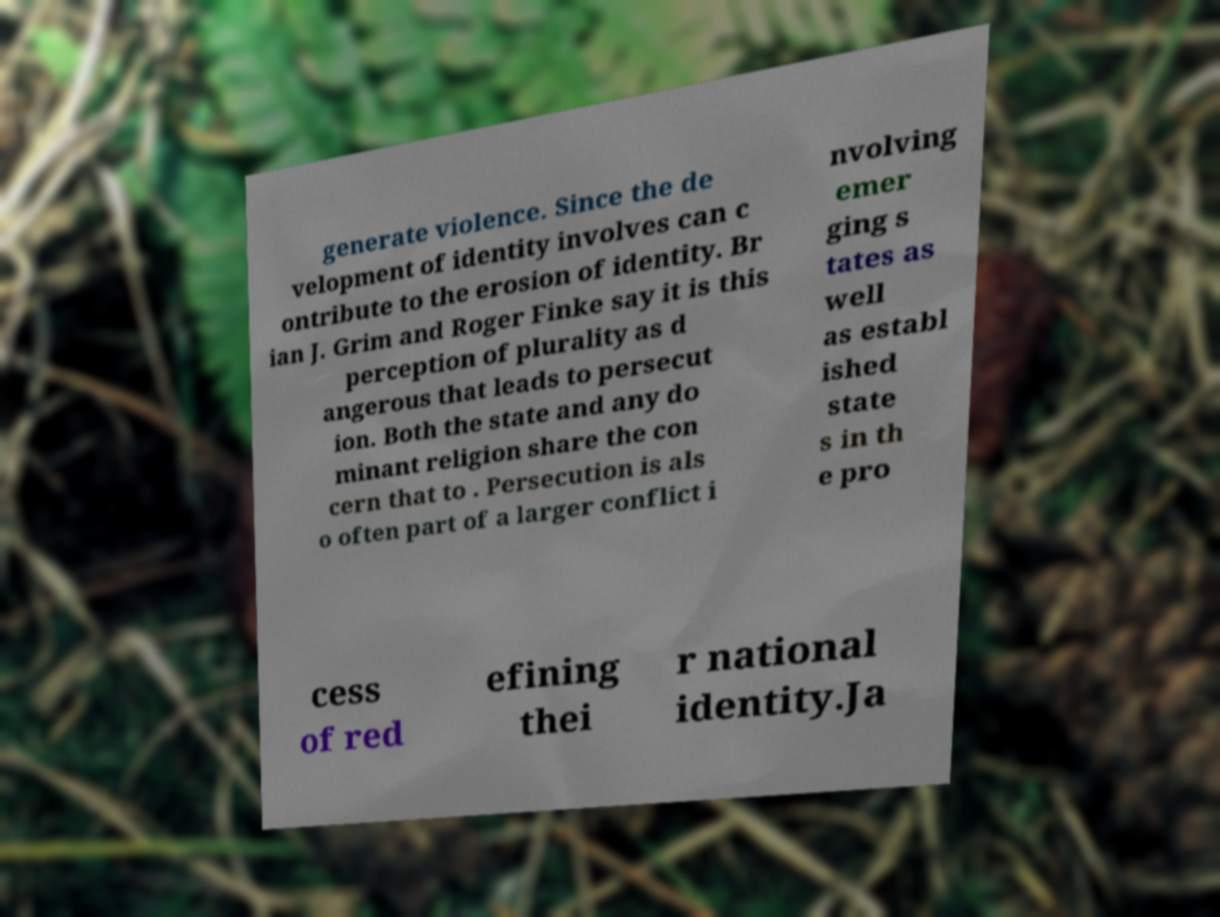Please identify and transcribe the text found in this image. generate violence. Since the de velopment of identity involves can c ontribute to the erosion of identity. Br ian J. Grim and Roger Finke say it is this perception of plurality as d angerous that leads to persecut ion. Both the state and any do minant religion share the con cern that to . Persecution is als o often part of a larger conflict i nvolving emer ging s tates as well as establ ished state s in th e pro cess of red efining thei r national identity.Ja 